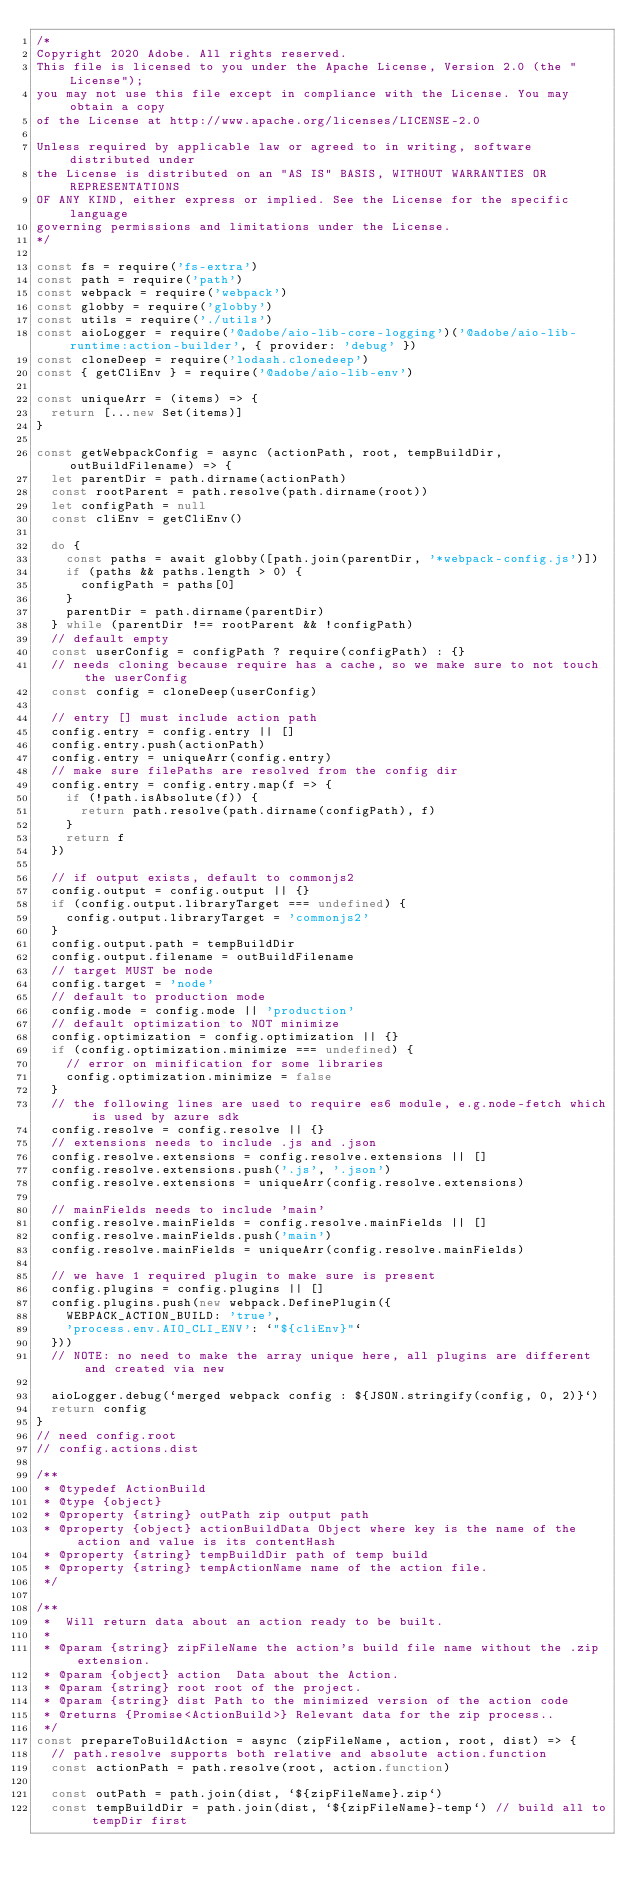<code> <loc_0><loc_0><loc_500><loc_500><_JavaScript_>/*
Copyright 2020 Adobe. All rights reserved.
This file is licensed to you under the Apache License, Version 2.0 (the "License");
you may not use this file except in compliance with the License. You may obtain a copy
of the License at http://www.apache.org/licenses/LICENSE-2.0

Unless required by applicable law or agreed to in writing, software distributed under
the License is distributed on an "AS IS" BASIS, WITHOUT WARRANTIES OR REPRESENTATIONS
OF ANY KIND, either express or implied. See the License for the specific language
governing permissions and limitations under the License.
*/

const fs = require('fs-extra')
const path = require('path')
const webpack = require('webpack')
const globby = require('globby')
const utils = require('./utils')
const aioLogger = require('@adobe/aio-lib-core-logging')('@adobe/aio-lib-runtime:action-builder', { provider: 'debug' })
const cloneDeep = require('lodash.clonedeep')
const { getCliEnv } = require('@adobe/aio-lib-env')

const uniqueArr = (items) => {
  return [...new Set(items)]
}

const getWebpackConfig = async (actionPath, root, tempBuildDir, outBuildFilename) => {
  let parentDir = path.dirname(actionPath)
  const rootParent = path.resolve(path.dirname(root))
  let configPath = null
  const cliEnv = getCliEnv()

  do {
    const paths = await globby([path.join(parentDir, '*webpack-config.js')])
    if (paths && paths.length > 0) {
      configPath = paths[0]
    }
    parentDir = path.dirname(parentDir)
  } while (parentDir !== rootParent && !configPath)
  // default empty
  const userConfig = configPath ? require(configPath) : {}
  // needs cloning because require has a cache, so we make sure to not touch the userConfig
  const config = cloneDeep(userConfig)

  // entry [] must include action path
  config.entry = config.entry || []
  config.entry.push(actionPath)
  config.entry = uniqueArr(config.entry)
  // make sure filePaths are resolved from the config dir
  config.entry = config.entry.map(f => {
    if (!path.isAbsolute(f)) {
      return path.resolve(path.dirname(configPath), f)
    }
    return f
  })

  // if output exists, default to commonjs2
  config.output = config.output || {}
  if (config.output.libraryTarget === undefined) {
    config.output.libraryTarget = 'commonjs2'
  }
  config.output.path = tempBuildDir
  config.output.filename = outBuildFilename
  // target MUST be node
  config.target = 'node'
  // default to production mode
  config.mode = config.mode || 'production'
  // default optimization to NOT minimize
  config.optimization = config.optimization || {}
  if (config.optimization.minimize === undefined) {
    // error on minification for some libraries
    config.optimization.minimize = false
  }
  // the following lines are used to require es6 module, e.g.node-fetch which is used by azure sdk
  config.resolve = config.resolve || {}
  // extensions needs to include .js and .json
  config.resolve.extensions = config.resolve.extensions || []
  config.resolve.extensions.push('.js', '.json')
  config.resolve.extensions = uniqueArr(config.resolve.extensions)

  // mainFields needs to include 'main'
  config.resolve.mainFields = config.resolve.mainFields || []
  config.resolve.mainFields.push('main')
  config.resolve.mainFields = uniqueArr(config.resolve.mainFields)

  // we have 1 required plugin to make sure is present
  config.plugins = config.plugins || []
  config.plugins.push(new webpack.DefinePlugin({
    WEBPACK_ACTION_BUILD: 'true',
    'process.env.AIO_CLI_ENV': `"${cliEnv}"`
  }))
  // NOTE: no need to make the array unique here, all plugins are different and created via new

  aioLogger.debug(`merged webpack config : ${JSON.stringify(config, 0, 2)}`)
  return config
}
// need config.root
// config.actions.dist

/**
 * @typedef ActionBuild
 * @type {object}
 * @property {string} outPath zip output path
 * @property {object} actionBuildData Object where key is the name of the action and value is its contentHash
 * @property {string} tempBuildDir path of temp build
 * @property {string} tempActionName name of the action file.
 */

/**
 *  Will return data about an action ready to be built.
 *
 * @param {string} zipFileName the action's build file name without the .zip extension.
 * @param {object} action  Data about the Action.
 * @param {string} root root of the project.
 * @param {string} dist Path to the minimized version of the action code
 * @returns {Promise<ActionBuild>} Relevant data for the zip process..
 */
const prepareToBuildAction = async (zipFileName, action, root, dist) => {
  // path.resolve supports both relative and absolute action.function
  const actionPath = path.resolve(root, action.function)

  const outPath = path.join(dist, `${zipFileName}.zip`)
  const tempBuildDir = path.join(dist, `${zipFileName}-temp`) // build all to tempDir first</code> 